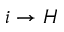<formula> <loc_0><loc_0><loc_500><loc_500>i \to { H }</formula> 